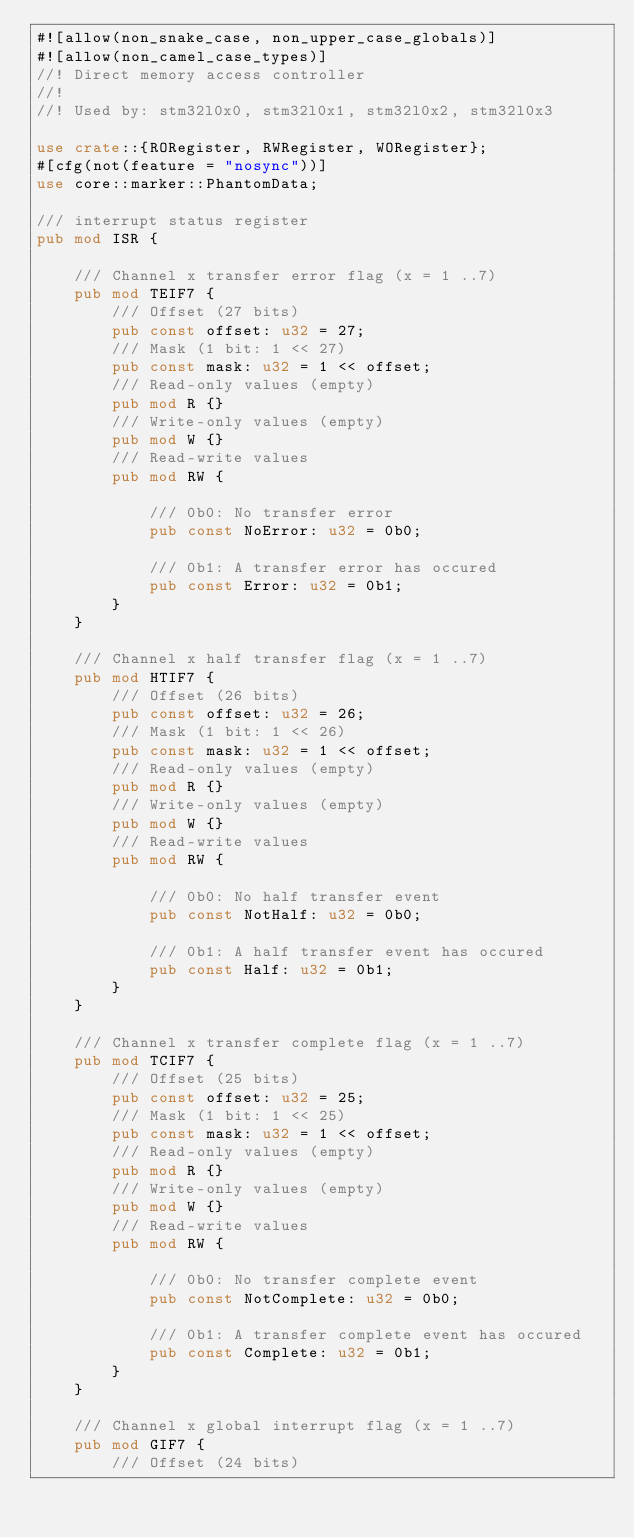<code> <loc_0><loc_0><loc_500><loc_500><_Rust_>#![allow(non_snake_case, non_upper_case_globals)]
#![allow(non_camel_case_types)]
//! Direct memory access controller
//!
//! Used by: stm32l0x0, stm32l0x1, stm32l0x2, stm32l0x3

use crate::{RORegister, RWRegister, WORegister};
#[cfg(not(feature = "nosync"))]
use core::marker::PhantomData;

/// interrupt status register
pub mod ISR {

    /// Channel x transfer error flag (x = 1 ..7)
    pub mod TEIF7 {
        /// Offset (27 bits)
        pub const offset: u32 = 27;
        /// Mask (1 bit: 1 << 27)
        pub const mask: u32 = 1 << offset;
        /// Read-only values (empty)
        pub mod R {}
        /// Write-only values (empty)
        pub mod W {}
        /// Read-write values
        pub mod RW {

            /// 0b0: No transfer error
            pub const NoError: u32 = 0b0;

            /// 0b1: A transfer error has occured
            pub const Error: u32 = 0b1;
        }
    }

    /// Channel x half transfer flag (x = 1 ..7)
    pub mod HTIF7 {
        /// Offset (26 bits)
        pub const offset: u32 = 26;
        /// Mask (1 bit: 1 << 26)
        pub const mask: u32 = 1 << offset;
        /// Read-only values (empty)
        pub mod R {}
        /// Write-only values (empty)
        pub mod W {}
        /// Read-write values
        pub mod RW {

            /// 0b0: No half transfer event
            pub const NotHalf: u32 = 0b0;

            /// 0b1: A half transfer event has occured
            pub const Half: u32 = 0b1;
        }
    }

    /// Channel x transfer complete flag (x = 1 ..7)
    pub mod TCIF7 {
        /// Offset (25 bits)
        pub const offset: u32 = 25;
        /// Mask (1 bit: 1 << 25)
        pub const mask: u32 = 1 << offset;
        /// Read-only values (empty)
        pub mod R {}
        /// Write-only values (empty)
        pub mod W {}
        /// Read-write values
        pub mod RW {

            /// 0b0: No transfer complete event
            pub const NotComplete: u32 = 0b0;

            /// 0b1: A transfer complete event has occured
            pub const Complete: u32 = 0b1;
        }
    }

    /// Channel x global interrupt flag (x = 1 ..7)
    pub mod GIF7 {
        /// Offset (24 bits)</code> 